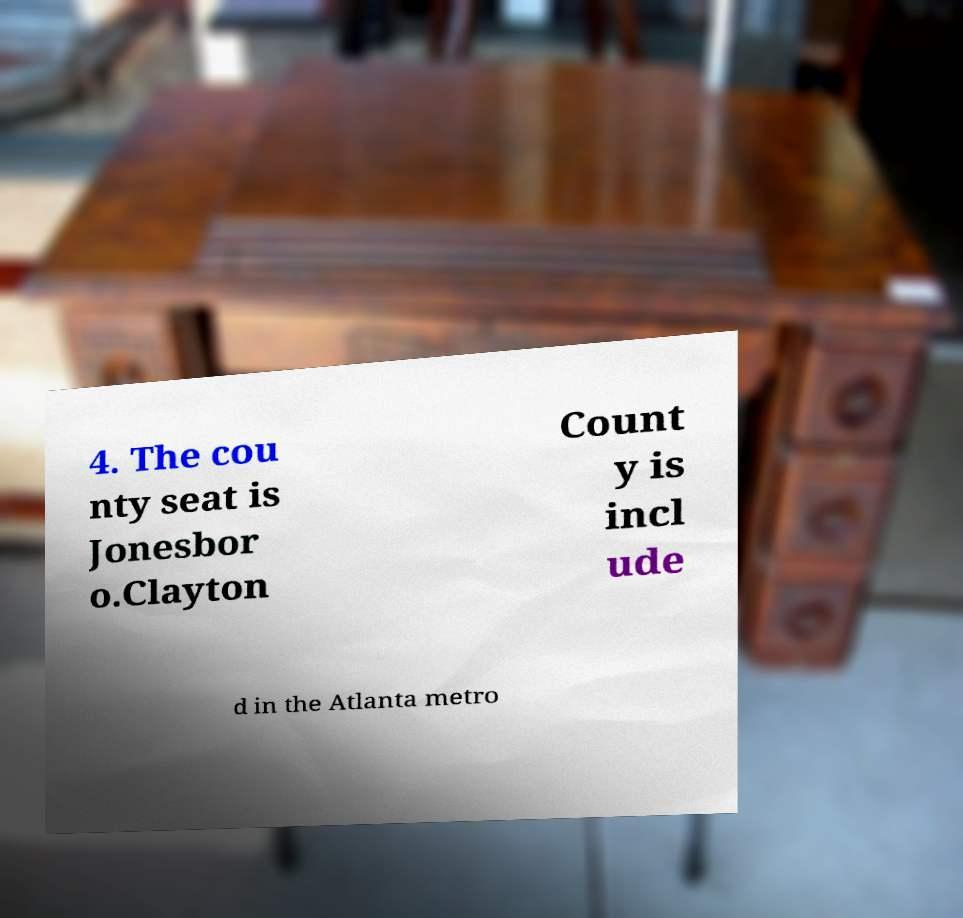There's text embedded in this image that I need extracted. Can you transcribe it verbatim? 4. The cou nty seat is Jonesbor o.Clayton Count y is incl ude d in the Atlanta metro 